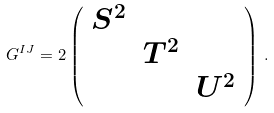<formula> <loc_0><loc_0><loc_500><loc_500>G ^ { I J } = 2 \left ( \begin{array} { c c c } S ^ { 2 } & & \\ & T ^ { 2 } & \\ & & U ^ { 2 } \end{array} \right ) \, .</formula> 